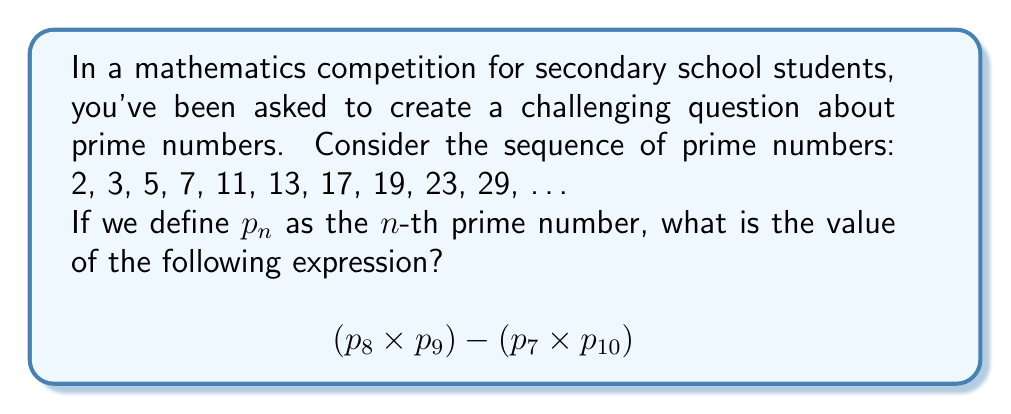Provide a solution to this math problem. Let's approach this step-by-step:

1) First, we need to identify the prime numbers in the sequence:
   $p_1 = 2$, $p_2 = 3$, $p_3 = 5$, $p_4 = 7$, $p_5 = 11$, $p_6 = 13$, $p_7 = 17$, $p_8 = 19$, $p_9 = 23$, $p_{10} = 29$

2) Now, let's substitute these values into our expression:
   $$(p_8 \times p_9) - (p_7 \times p_{10})$$
   $$(19 \times 23) - (17 \times 29)$$

3) Let's calculate the first part:
   $19 \times 23 = 437$

4) Now the second part:
   $17 \times 29 = 493$

5) Finally, we can subtract:
   $437 - 493 = -56$

Therefore, the value of the expression is -56.
Answer: -56 